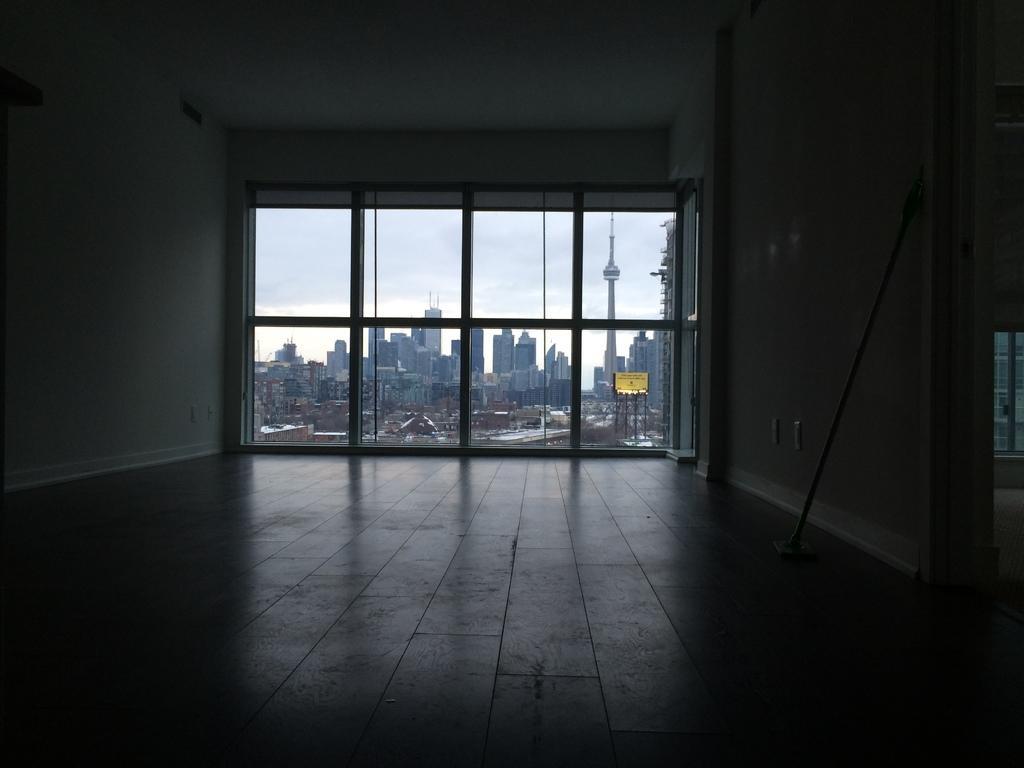How would you summarize this image in a sentence or two? This is an inside view of a room. We can see a window. There are some buildings and a board on the poles in the background.. 